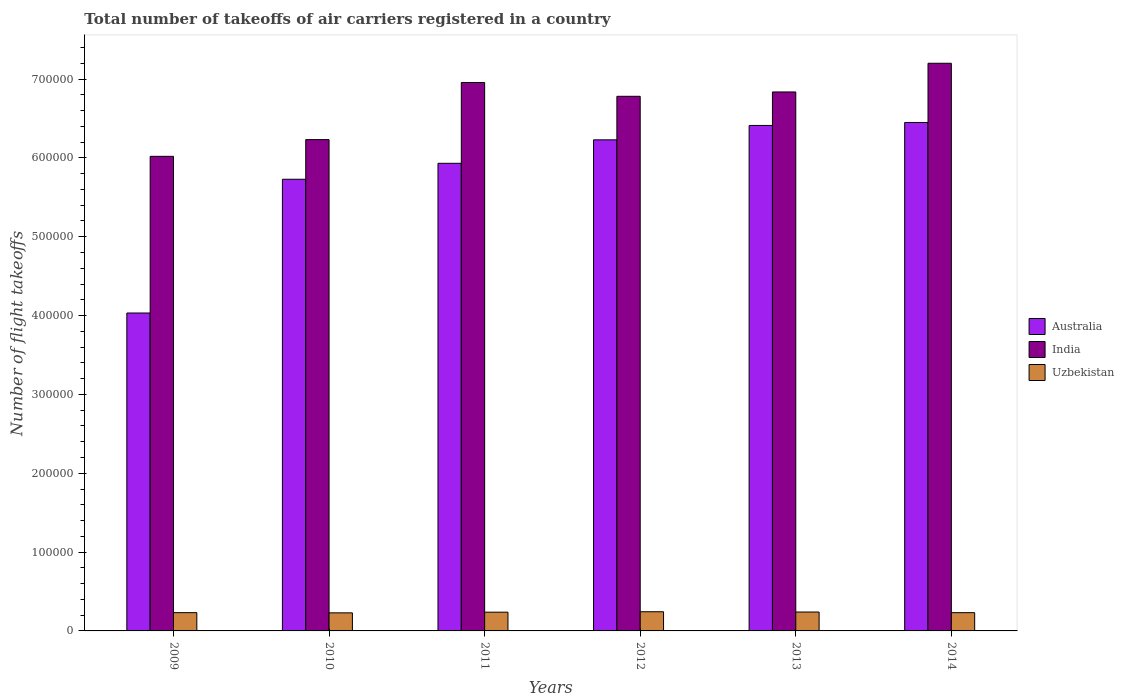Are the number of bars on each tick of the X-axis equal?
Provide a succinct answer. Yes. How many bars are there on the 4th tick from the right?
Ensure brevity in your answer.  3. What is the total number of flight takeoffs in Australia in 2011?
Provide a succinct answer. 5.93e+05. Across all years, what is the maximum total number of flight takeoffs in Uzbekistan?
Provide a succinct answer. 2.43e+04. Across all years, what is the minimum total number of flight takeoffs in India?
Give a very brief answer. 6.02e+05. In which year was the total number of flight takeoffs in India maximum?
Make the answer very short. 2014. What is the total total number of flight takeoffs in Uzbekistan in the graph?
Ensure brevity in your answer.  1.41e+05. What is the difference between the total number of flight takeoffs in India in 2010 and that in 2012?
Keep it short and to the point. -5.49e+04. What is the difference between the total number of flight takeoffs in India in 2014 and the total number of flight takeoffs in Uzbekistan in 2013?
Offer a terse response. 6.96e+05. What is the average total number of flight takeoffs in Uzbekistan per year?
Provide a succinct answer. 2.36e+04. In the year 2013, what is the difference between the total number of flight takeoffs in Uzbekistan and total number of flight takeoffs in Australia?
Make the answer very short. -6.17e+05. In how many years, is the total number of flight takeoffs in Australia greater than 200000?
Make the answer very short. 6. What is the ratio of the total number of flight takeoffs in Uzbekistan in 2009 to that in 2010?
Your answer should be compact. 1.01. What is the difference between the highest and the second highest total number of flight takeoffs in India?
Make the answer very short. 2.44e+04. What is the difference between the highest and the lowest total number of flight takeoffs in Australia?
Provide a succinct answer. 2.42e+05. In how many years, is the total number of flight takeoffs in Australia greater than the average total number of flight takeoffs in Australia taken over all years?
Make the answer very short. 4. What does the 1st bar from the left in 2014 represents?
Keep it short and to the point. Australia. How many years are there in the graph?
Provide a succinct answer. 6. Are the values on the major ticks of Y-axis written in scientific E-notation?
Offer a very short reply. No. How many legend labels are there?
Offer a terse response. 3. How are the legend labels stacked?
Offer a terse response. Vertical. What is the title of the graph?
Keep it short and to the point. Total number of takeoffs of air carriers registered in a country. What is the label or title of the X-axis?
Give a very brief answer. Years. What is the label or title of the Y-axis?
Your answer should be very brief. Number of flight takeoffs. What is the Number of flight takeoffs of Australia in 2009?
Your response must be concise. 4.03e+05. What is the Number of flight takeoffs of India in 2009?
Offer a very short reply. 6.02e+05. What is the Number of flight takeoffs in Uzbekistan in 2009?
Your answer should be very brief. 2.32e+04. What is the Number of flight takeoffs in Australia in 2010?
Make the answer very short. 5.73e+05. What is the Number of flight takeoffs of India in 2010?
Ensure brevity in your answer.  6.23e+05. What is the Number of flight takeoffs of Uzbekistan in 2010?
Your answer should be compact. 2.29e+04. What is the Number of flight takeoffs of Australia in 2011?
Give a very brief answer. 5.93e+05. What is the Number of flight takeoffs of India in 2011?
Your answer should be very brief. 6.96e+05. What is the Number of flight takeoffs in Uzbekistan in 2011?
Ensure brevity in your answer.  2.38e+04. What is the Number of flight takeoffs in Australia in 2012?
Offer a very short reply. 6.23e+05. What is the Number of flight takeoffs in India in 2012?
Keep it short and to the point. 6.78e+05. What is the Number of flight takeoffs of Uzbekistan in 2012?
Provide a succinct answer. 2.43e+04. What is the Number of flight takeoffs of Australia in 2013?
Offer a very short reply. 6.41e+05. What is the Number of flight takeoffs in India in 2013?
Keep it short and to the point. 6.84e+05. What is the Number of flight takeoffs of Uzbekistan in 2013?
Your response must be concise. 2.40e+04. What is the Number of flight takeoffs of Australia in 2014?
Your response must be concise. 6.45e+05. What is the Number of flight takeoffs in India in 2014?
Offer a terse response. 7.20e+05. What is the Number of flight takeoffs in Uzbekistan in 2014?
Ensure brevity in your answer.  2.31e+04. Across all years, what is the maximum Number of flight takeoffs in Australia?
Provide a short and direct response. 6.45e+05. Across all years, what is the maximum Number of flight takeoffs of India?
Provide a succinct answer. 7.20e+05. Across all years, what is the maximum Number of flight takeoffs in Uzbekistan?
Offer a very short reply. 2.43e+04. Across all years, what is the minimum Number of flight takeoffs in Australia?
Keep it short and to the point. 4.03e+05. Across all years, what is the minimum Number of flight takeoffs in India?
Your response must be concise. 6.02e+05. Across all years, what is the minimum Number of flight takeoffs of Uzbekistan?
Offer a very short reply. 2.29e+04. What is the total Number of flight takeoffs in Australia in the graph?
Your response must be concise. 3.48e+06. What is the total Number of flight takeoffs of India in the graph?
Make the answer very short. 4.00e+06. What is the total Number of flight takeoffs of Uzbekistan in the graph?
Give a very brief answer. 1.41e+05. What is the difference between the Number of flight takeoffs in Australia in 2009 and that in 2010?
Your response must be concise. -1.70e+05. What is the difference between the Number of flight takeoffs of India in 2009 and that in 2010?
Provide a short and direct response. -2.12e+04. What is the difference between the Number of flight takeoffs in Uzbekistan in 2009 and that in 2010?
Offer a terse response. 252. What is the difference between the Number of flight takeoffs in Australia in 2009 and that in 2011?
Your answer should be very brief. -1.90e+05. What is the difference between the Number of flight takeoffs in India in 2009 and that in 2011?
Keep it short and to the point. -9.36e+04. What is the difference between the Number of flight takeoffs of Uzbekistan in 2009 and that in 2011?
Offer a very short reply. -597. What is the difference between the Number of flight takeoffs of Australia in 2009 and that in 2012?
Ensure brevity in your answer.  -2.20e+05. What is the difference between the Number of flight takeoffs of India in 2009 and that in 2012?
Offer a very short reply. -7.61e+04. What is the difference between the Number of flight takeoffs of Uzbekistan in 2009 and that in 2012?
Your answer should be very brief. -1152. What is the difference between the Number of flight takeoffs of Australia in 2009 and that in 2013?
Offer a terse response. -2.38e+05. What is the difference between the Number of flight takeoffs of India in 2009 and that in 2013?
Offer a very short reply. -8.17e+04. What is the difference between the Number of flight takeoffs of Uzbekistan in 2009 and that in 2013?
Offer a terse response. -786. What is the difference between the Number of flight takeoffs of Australia in 2009 and that in 2014?
Ensure brevity in your answer.  -2.42e+05. What is the difference between the Number of flight takeoffs in India in 2009 and that in 2014?
Make the answer very short. -1.18e+05. What is the difference between the Number of flight takeoffs of Australia in 2010 and that in 2011?
Offer a terse response. -2.02e+04. What is the difference between the Number of flight takeoffs in India in 2010 and that in 2011?
Your answer should be compact. -7.24e+04. What is the difference between the Number of flight takeoffs in Uzbekistan in 2010 and that in 2011?
Provide a short and direct response. -849. What is the difference between the Number of flight takeoffs of Australia in 2010 and that in 2012?
Your answer should be compact. -5.00e+04. What is the difference between the Number of flight takeoffs of India in 2010 and that in 2012?
Provide a succinct answer. -5.49e+04. What is the difference between the Number of flight takeoffs of Uzbekistan in 2010 and that in 2012?
Your answer should be very brief. -1404. What is the difference between the Number of flight takeoffs in Australia in 2010 and that in 2013?
Your answer should be compact. -6.83e+04. What is the difference between the Number of flight takeoffs in India in 2010 and that in 2013?
Your response must be concise. -6.05e+04. What is the difference between the Number of flight takeoffs in Uzbekistan in 2010 and that in 2013?
Your answer should be very brief. -1038. What is the difference between the Number of flight takeoffs in Australia in 2010 and that in 2014?
Provide a succinct answer. -7.20e+04. What is the difference between the Number of flight takeoffs in India in 2010 and that in 2014?
Your response must be concise. -9.69e+04. What is the difference between the Number of flight takeoffs in Uzbekistan in 2010 and that in 2014?
Ensure brevity in your answer.  -225. What is the difference between the Number of flight takeoffs in Australia in 2011 and that in 2012?
Give a very brief answer. -2.98e+04. What is the difference between the Number of flight takeoffs in India in 2011 and that in 2012?
Ensure brevity in your answer.  1.75e+04. What is the difference between the Number of flight takeoffs of Uzbekistan in 2011 and that in 2012?
Your answer should be compact. -555. What is the difference between the Number of flight takeoffs of Australia in 2011 and that in 2013?
Your response must be concise. -4.80e+04. What is the difference between the Number of flight takeoffs in India in 2011 and that in 2013?
Provide a short and direct response. 1.20e+04. What is the difference between the Number of flight takeoffs in Uzbekistan in 2011 and that in 2013?
Your answer should be compact. -189. What is the difference between the Number of flight takeoffs in Australia in 2011 and that in 2014?
Offer a terse response. -5.18e+04. What is the difference between the Number of flight takeoffs in India in 2011 and that in 2014?
Keep it short and to the point. -2.44e+04. What is the difference between the Number of flight takeoffs in Uzbekistan in 2011 and that in 2014?
Offer a very short reply. 624. What is the difference between the Number of flight takeoffs in Australia in 2012 and that in 2013?
Make the answer very short. -1.83e+04. What is the difference between the Number of flight takeoffs of India in 2012 and that in 2013?
Offer a terse response. -5520.87. What is the difference between the Number of flight takeoffs in Uzbekistan in 2012 and that in 2013?
Keep it short and to the point. 366. What is the difference between the Number of flight takeoffs in Australia in 2012 and that in 2014?
Keep it short and to the point. -2.20e+04. What is the difference between the Number of flight takeoffs of India in 2012 and that in 2014?
Your answer should be very brief. -4.19e+04. What is the difference between the Number of flight takeoffs in Uzbekistan in 2012 and that in 2014?
Your answer should be compact. 1179. What is the difference between the Number of flight takeoffs in Australia in 2013 and that in 2014?
Keep it short and to the point. -3761.86. What is the difference between the Number of flight takeoffs in India in 2013 and that in 2014?
Keep it short and to the point. -3.64e+04. What is the difference between the Number of flight takeoffs in Uzbekistan in 2013 and that in 2014?
Provide a short and direct response. 813. What is the difference between the Number of flight takeoffs of Australia in 2009 and the Number of flight takeoffs of India in 2010?
Your answer should be compact. -2.20e+05. What is the difference between the Number of flight takeoffs in Australia in 2009 and the Number of flight takeoffs in Uzbekistan in 2010?
Provide a short and direct response. 3.80e+05. What is the difference between the Number of flight takeoffs of India in 2009 and the Number of flight takeoffs of Uzbekistan in 2010?
Your response must be concise. 5.79e+05. What is the difference between the Number of flight takeoffs of Australia in 2009 and the Number of flight takeoffs of India in 2011?
Give a very brief answer. -2.92e+05. What is the difference between the Number of flight takeoffs in Australia in 2009 and the Number of flight takeoffs in Uzbekistan in 2011?
Provide a succinct answer. 3.79e+05. What is the difference between the Number of flight takeoffs in India in 2009 and the Number of flight takeoffs in Uzbekistan in 2011?
Make the answer very short. 5.78e+05. What is the difference between the Number of flight takeoffs of Australia in 2009 and the Number of flight takeoffs of India in 2012?
Offer a terse response. -2.75e+05. What is the difference between the Number of flight takeoffs of Australia in 2009 and the Number of flight takeoffs of Uzbekistan in 2012?
Give a very brief answer. 3.79e+05. What is the difference between the Number of flight takeoffs in India in 2009 and the Number of flight takeoffs in Uzbekistan in 2012?
Provide a short and direct response. 5.78e+05. What is the difference between the Number of flight takeoffs of Australia in 2009 and the Number of flight takeoffs of India in 2013?
Provide a succinct answer. -2.80e+05. What is the difference between the Number of flight takeoffs in Australia in 2009 and the Number of flight takeoffs in Uzbekistan in 2013?
Offer a terse response. 3.79e+05. What is the difference between the Number of flight takeoffs of India in 2009 and the Number of flight takeoffs of Uzbekistan in 2013?
Your answer should be very brief. 5.78e+05. What is the difference between the Number of flight takeoffs in Australia in 2009 and the Number of flight takeoffs in India in 2014?
Offer a very short reply. -3.17e+05. What is the difference between the Number of flight takeoffs in Australia in 2009 and the Number of flight takeoffs in Uzbekistan in 2014?
Your answer should be compact. 3.80e+05. What is the difference between the Number of flight takeoffs in India in 2009 and the Number of flight takeoffs in Uzbekistan in 2014?
Provide a short and direct response. 5.79e+05. What is the difference between the Number of flight takeoffs of Australia in 2010 and the Number of flight takeoffs of India in 2011?
Make the answer very short. -1.23e+05. What is the difference between the Number of flight takeoffs in Australia in 2010 and the Number of flight takeoffs in Uzbekistan in 2011?
Give a very brief answer. 5.49e+05. What is the difference between the Number of flight takeoffs in India in 2010 and the Number of flight takeoffs in Uzbekistan in 2011?
Keep it short and to the point. 5.99e+05. What is the difference between the Number of flight takeoffs in Australia in 2010 and the Number of flight takeoffs in India in 2012?
Offer a terse response. -1.05e+05. What is the difference between the Number of flight takeoffs in Australia in 2010 and the Number of flight takeoffs in Uzbekistan in 2012?
Your response must be concise. 5.49e+05. What is the difference between the Number of flight takeoffs of India in 2010 and the Number of flight takeoffs of Uzbekistan in 2012?
Provide a succinct answer. 5.99e+05. What is the difference between the Number of flight takeoffs of Australia in 2010 and the Number of flight takeoffs of India in 2013?
Your answer should be very brief. -1.11e+05. What is the difference between the Number of flight takeoffs in Australia in 2010 and the Number of flight takeoffs in Uzbekistan in 2013?
Your answer should be compact. 5.49e+05. What is the difference between the Number of flight takeoffs of India in 2010 and the Number of flight takeoffs of Uzbekistan in 2013?
Offer a very short reply. 5.99e+05. What is the difference between the Number of flight takeoffs in Australia in 2010 and the Number of flight takeoffs in India in 2014?
Give a very brief answer. -1.47e+05. What is the difference between the Number of flight takeoffs in Australia in 2010 and the Number of flight takeoffs in Uzbekistan in 2014?
Offer a terse response. 5.50e+05. What is the difference between the Number of flight takeoffs in India in 2010 and the Number of flight takeoffs in Uzbekistan in 2014?
Your response must be concise. 6.00e+05. What is the difference between the Number of flight takeoffs of Australia in 2011 and the Number of flight takeoffs of India in 2012?
Give a very brief answer. -8.50e+04. What is the difference between the Number of flight takeoffs in Australia in 2011 and the Number of flight takeoffs in Uzbekistan in 2012?
Give a very brief answer. 5.69e+05. What is the difference between the Number of flight takeoffs in India in 2011 and the Number of flight takeoffs in Uzbekistan in 2012?
Give a very brief answer. 6.71e+05. What is the difference between the Number of flight takeoffs in Australia in 2011 and the Number of flight takeoffs in India in 2013?
Make the answer very short. -9.05e+04. What is the difference between the Number of flight takeoffs of Australia in 2011 and the Number of flight takeoffs of Uzbekistan in 2013?
Keep it short and to the point. 5.69e+05. What is the difference between the Number of flight takeoffs of India in 2011 and the Number of flight takeoffs of Uzbekistan in 2013?
Your answer should be compact. 6.72e+05. What is the difference between the Number of flight takeoffs in Australia in 2011 and the Number of flight takeoffs in India in 2014?
Give a very brief answer. -1.27e+05. What is the difference between the Number of flight takeoffs in Australia in 2011 and the Number of flight takeoffs in Uzbekistan in 2014?
Your answer should be compact. 5.70e+05. What is the difference between the Number of flight takeoffs in India in 2011 and the Number of flight takeoffs in Uzbekistan in 2014?
Provide a succinct answer. 6.72e+05. What is the difference between the Number of flight takeoffs in Australia in 2012 and the Number of flight takeoffs in India in 2013?
Provide a succinct answer. -6.07e+04. What is the difference between the Number of flight takeoffs of Australia in 2012 and the Number of flight takeoffs of Uzbekistan in 2013?
Ensure brevity in your answer.  5.99e+05. What is the difference between the Number of flight takeoffs of India in 2012 and the Number of flight takeoffs of Uzbekistan in 2013?
Provide a short and direct response. 6.54e+05. What is the difference between the Number of flight takeoffs of Australia in 2012 and the Number of flight takeoffs of India in 2014?
Offer a terse response. -9.71e+04. What is the difference between the Number of flight takeoffs in Australia in 2012 and the Number of flight takeoffs in Uzbekistan in 2014?
Make the answer very short. 6.00e+05. What is the difference between the Number of flight takeoffs of India in 2012 and the Number of flight takeoffs of Uzbekistan in 2014?
Offer a very short reply. 6.55e+05. What is the difference between the Number of flight takeoffs of Australia in 2013 and the Number of flight takeoffs of India in 2014?
Provide a succinct answer. -7.89e+04. What is the difference between the Number of flight takeoffs in Australia in 2013 and the Number of flight takeoffs in Uzbekistan in 2014?
Make the answer very short. 6.18e+05. What is the difference between the Number of flight takeoffs in India in 2013 and the Number of flight takeoffs in Uzbekistan in 2014?
Provide a short and direct response. 6.60e+05. What is the average Number of flight takeoffs of Australia per year?
Give a very brief answer. 5.80e+05. What is the average Number of flight takeoffs in India per year?
Give a very brief answer. 6.67e+05. What is the average Number of flight takeoffs of Uzbekistan per year?
Provide a short and direct response. 2.36e+04. In the year 2009, what is the difference between the Number of flight takeoffs of Australia and Number of flight takeoffs of India?
Provide a succinct answer. -1.99e+05. In the year 2009, what is the difference between the Number of flight takeoffs in Australia and Number of flight takeoffs in Uzbekistan?
Provide a short and direct response. 3.80e+05. In the year 2009, what is the difference between the Number of flight takeoffs of India and Number of flight takeoffs of Uzbekistan?
Your answer should be compact. 5.79e+05. In the year 2010, what is the difference between the Number of flight takeoffs of Australia and Number of flight takeoffs of India?
Make the answer very short. -5.03e+04. In the year 2010, what is the difference between the Number of flight takeoffs of Australia and Number of flight takeoffs of Uzbekistan?
Give a very brief answer. 5.50e+05. In the year 2010, what is the difference between the Number of flight takeoffs of India and Number of flight takeoffs of Uzbekistan?
Your answer should be compact. 6.00e+05. In the year 2011, what is the difference between the Number of flight takeoffs of Australia and Number of flight takeoffs of India?
Keep it short and to the point. -1.02e+05. In the year 2011, what is the difference between the Number of flight takeoffs of Australia and Number of flight takeoffs of Uzbekistan?
Ensure brevity in your answer.  5.69e+05. In the year 2011, what is the difference between the Number of flight takeoffs of India and Number of flight takeoffs of Uzbekistan?
Your response must be concise. 6.72e+05. In the year 2012, what is the difference between the Number of flight takeoffs of Australia and Number of flight takeoffs of India?
Offer a very short reply. -5.52e+04. In the year 2012, what is the difference between the Number of flight takeoffs of Australia and Number of flight takeoffs of Uzbekistan?
Keep it short and to the point. 5.99e+05. In the year 2012, what is the difference between the Number of flight takeoffs in India and Number of flight takeoffs in Uzbekistan?
Provide a short and direct response. 6.54e+05. In the year 2013, what is the difference between the Number of flight takeoffs of Australia and Number of flight takeoffs of India?
Provide a succinct answer. -4.25e+04. In the year 2013, what is the difference between the Number of flight takeoffs in Australia and Number of flight takeoffs in Uzbekistan?
Provide a short and direct response. 6.17e+05. In the year 2013, what is the difference between the Number of flight takeoffs in India and Number of flight takeoffs in Uzbekistan?
Keep it short and to the point. 6.60e+05. In the year 2014, what is the difference between the Number of flight takeoffs in Australia and Number of flight takeoffs in India?
Provide a short and direct response. -7.51e+04. In the year 2014, what is the difference between the Number of flight takeoffs in Australia and Number of flight takeoffs in Uzbekistan?
Provide a short and direct response. 6.22e+05. In the year 2014, what is the difference between the Number of flight takeoffs of India and Number of flight takeoffs of Uzbekistan?
Make the answer very short. 6.97e+05. What is the ratio of the Number of flight takeoffs of Australia in 2009 to that in 2010?
Ensure brevity in your answer.  0.7. What is the ratio of the Number of flight takeoffs of India in 2009 to that in 2010?
Provide a succinct answer. 0.97. What is the ratio of the Number of flight takeoffs of Australia in 2009 to that in 2011?
Make the answer very short. 0.68. What is the ratio of the Number of flight takeoffs of India in 2009 to that in 2011?
Offer a very short reply. 0.87. What is the ratio of the Number of flight takeoffs of Uzbekistan in 2009 to that in 2011?
Ensure brevity in your answer.  0.97. What is the ratio of the Number of flight takeoffs of Australia in 2009 to that in 2012?
Ensure brevity in your answer.  0.65. What is the ratio of the Number of flight takeoffs of India in 2009 to that in 2012?
Your response must be concise. 0.89. What is the ratio of the Number of flight takeoffs of Uzbekistan in 2009 to that in 2012?
Offer a very short reply. 0.95. What is the ratio of the Number of flight takeoffs of Australia in 2009 to that in 2013?
Your answer should be very brief. 0.63. What is the ratio of the Number of flight takeoffs of India in 2009 to that in 2013?
Make the answer very short. 0.88. What is the ratio of the Number of flight takeoffs in Uzbekistan in 2009 to that in 2013?
Ensure brevity in your answer.  0.97. What is the ratio of the Number of flight takeoffs in Australia in 2009 to that in 2014?
Your answer should be very brief. 0.63. What is the ratio of the Number of flight takeoffs of India in 2009 to that in 2014?
Make the answer very short. 0.84. What is the ratio of the Number of flight takeoffs of Uzbekistan in 2009 to that in 2014?
Offer a terse response. 1. What is the ratio of the Number of flight takeoffs in Australia in 2010 to that in 2011?
Your response must be concise. 0.97. What is the ratio of the Number of flight takeoffs in India in 2010 to that in 2011?
Make the answer very short. 0.9. What is the ratio of the Number of flight takeoffs of Australia in 2010 to that in 2012?
Offer a very short reply. 0.92. What is the ratio of the Number of flight takeoffs in India in 2010 to that in 2012?
Keep it short and to the point. 0.92. What is the ratio of the Number of flight takeoffs of Uzbekistan in 2010 to that in 2012?
Ensure brevity in your answer.  0.94. What is the ratio of the Number of flight takeoffs of Australia in 2010 to that in 2013?
Your response must be concise. 0.89. What is the ratio of the Number of flight takeoffs in India in 2010 to that in 2013?
Provide a succinct answer. 0.91. What is the ratio of the Number of flight takeoffs of Uzbekistan in 2010 to that in 2013?
Give a very brief answer. 0.96. What is the ratio of the Number of flight takeoffs in Australia in 2010 to that in 2014?
Your response must be concise. 0.89. What is the ratio of the Number of flight takeoffs of India in 2010 to that in 2014?
Provide a succinct answer. 0.87. What is the ratio of the Number of flight takeoffs in Uzbekistan in 2010 to that in 2014?
Make the answer very short. 0.99. What is the ratio of the Number of flight takeoffs in Australia in 2011 to that in 2012?
Provide a short and direct response. 0.95. What is the ratio of the Number of flight takeoffs in India in 2011 to that in 2012?
Offer a terse response. 1.03. What is the ratio of the Number of flight takeoffs in Uzbekistan in 2011 to that in 2012?
Your answer should be compact. 0.98. What is the ratio of the Number of flight takeoffs in Australia in 2011 to that in 2013?
Provide a short and direct response. 0.93. What is the ratio of the Number of flight takeoffs in India in 2011 to that in 2013?
Ensure brevity in your answer.  1.02. What is the ratio of the Number of flight takeoffs of Uzbekistan in 2011 to that in 2013?
Your answer should be very brief. 0.99. What is the ratio of the Number of flight takeoffs of Australia in 2011 to that in 2014?
Keep it short and to the point. 0.92. What is the ratio of the Number of flight takeoffs of India in 2011 to that in 2014?
Make the answer very short. 0.97. What is the ratio of the Number of flight takeoffs of Australia in 2012 to that in 2013?
Make the answer very short. 0.97. What is the ratio of the Number of flight takeoffs in Uzbekistan in 2012 to that in 2013?
Provide a succinct answer. 1.02. What is the ratio of the Number of flight takeoffs of Australia in 2012 to that in 2014?
Make the answer very short. 0.97. What is the ratio of the Number of flight takeoffs of India in 2012 to that in 2014?
Keep it short and to the point. 0.94. What is the ratio of the Number of flight takeoffs in Uzbekistan in 2012 to that in 2014?
Offer a very short reply. 1.05. What is the ratio of the Number of flight takeoffs of India in 2013 to that in 2014?
Your answer should be compact. 0.95. What is the ratio of the Number of flight takeoffs of Uzbekistan in 2013 to that in 2014?
Give a very brief answer. 1.04. What is the difference between the highest and the second highest Number of flight takeoffs of Australia?
Ensure brevity in your answer.  3761.86. What is the difference between the highest and the second highest Number of flight takeoffs in India?
Make the answer very short. 2.44e+04. What is the difference between the highest and the second highest Number of flight takeoffs in Uzbekistan?
Make the answer very short. 366. What is the difference between the highest and the lowest Number of flight takeoffs in Australia?
Make the answer very short. 2.42e+05. What is the difference between the highest and the lowest Number of flight takeoffs in India?
Your response must be concise. 1.18e+05. What is the difference between the highest and the lowest Number of flight takeoffs of Uzbekistan?
Ensure brevity in your answer.  1404. 